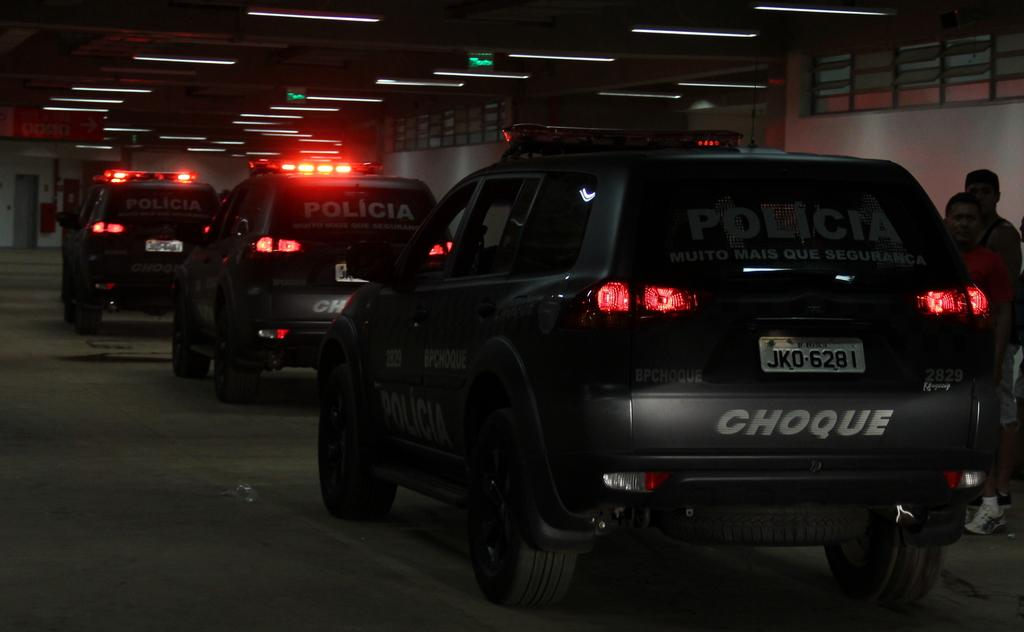<image>
Relay a brief, clear account of the picture shown. Black car in traffic with the word Policia on the back. 